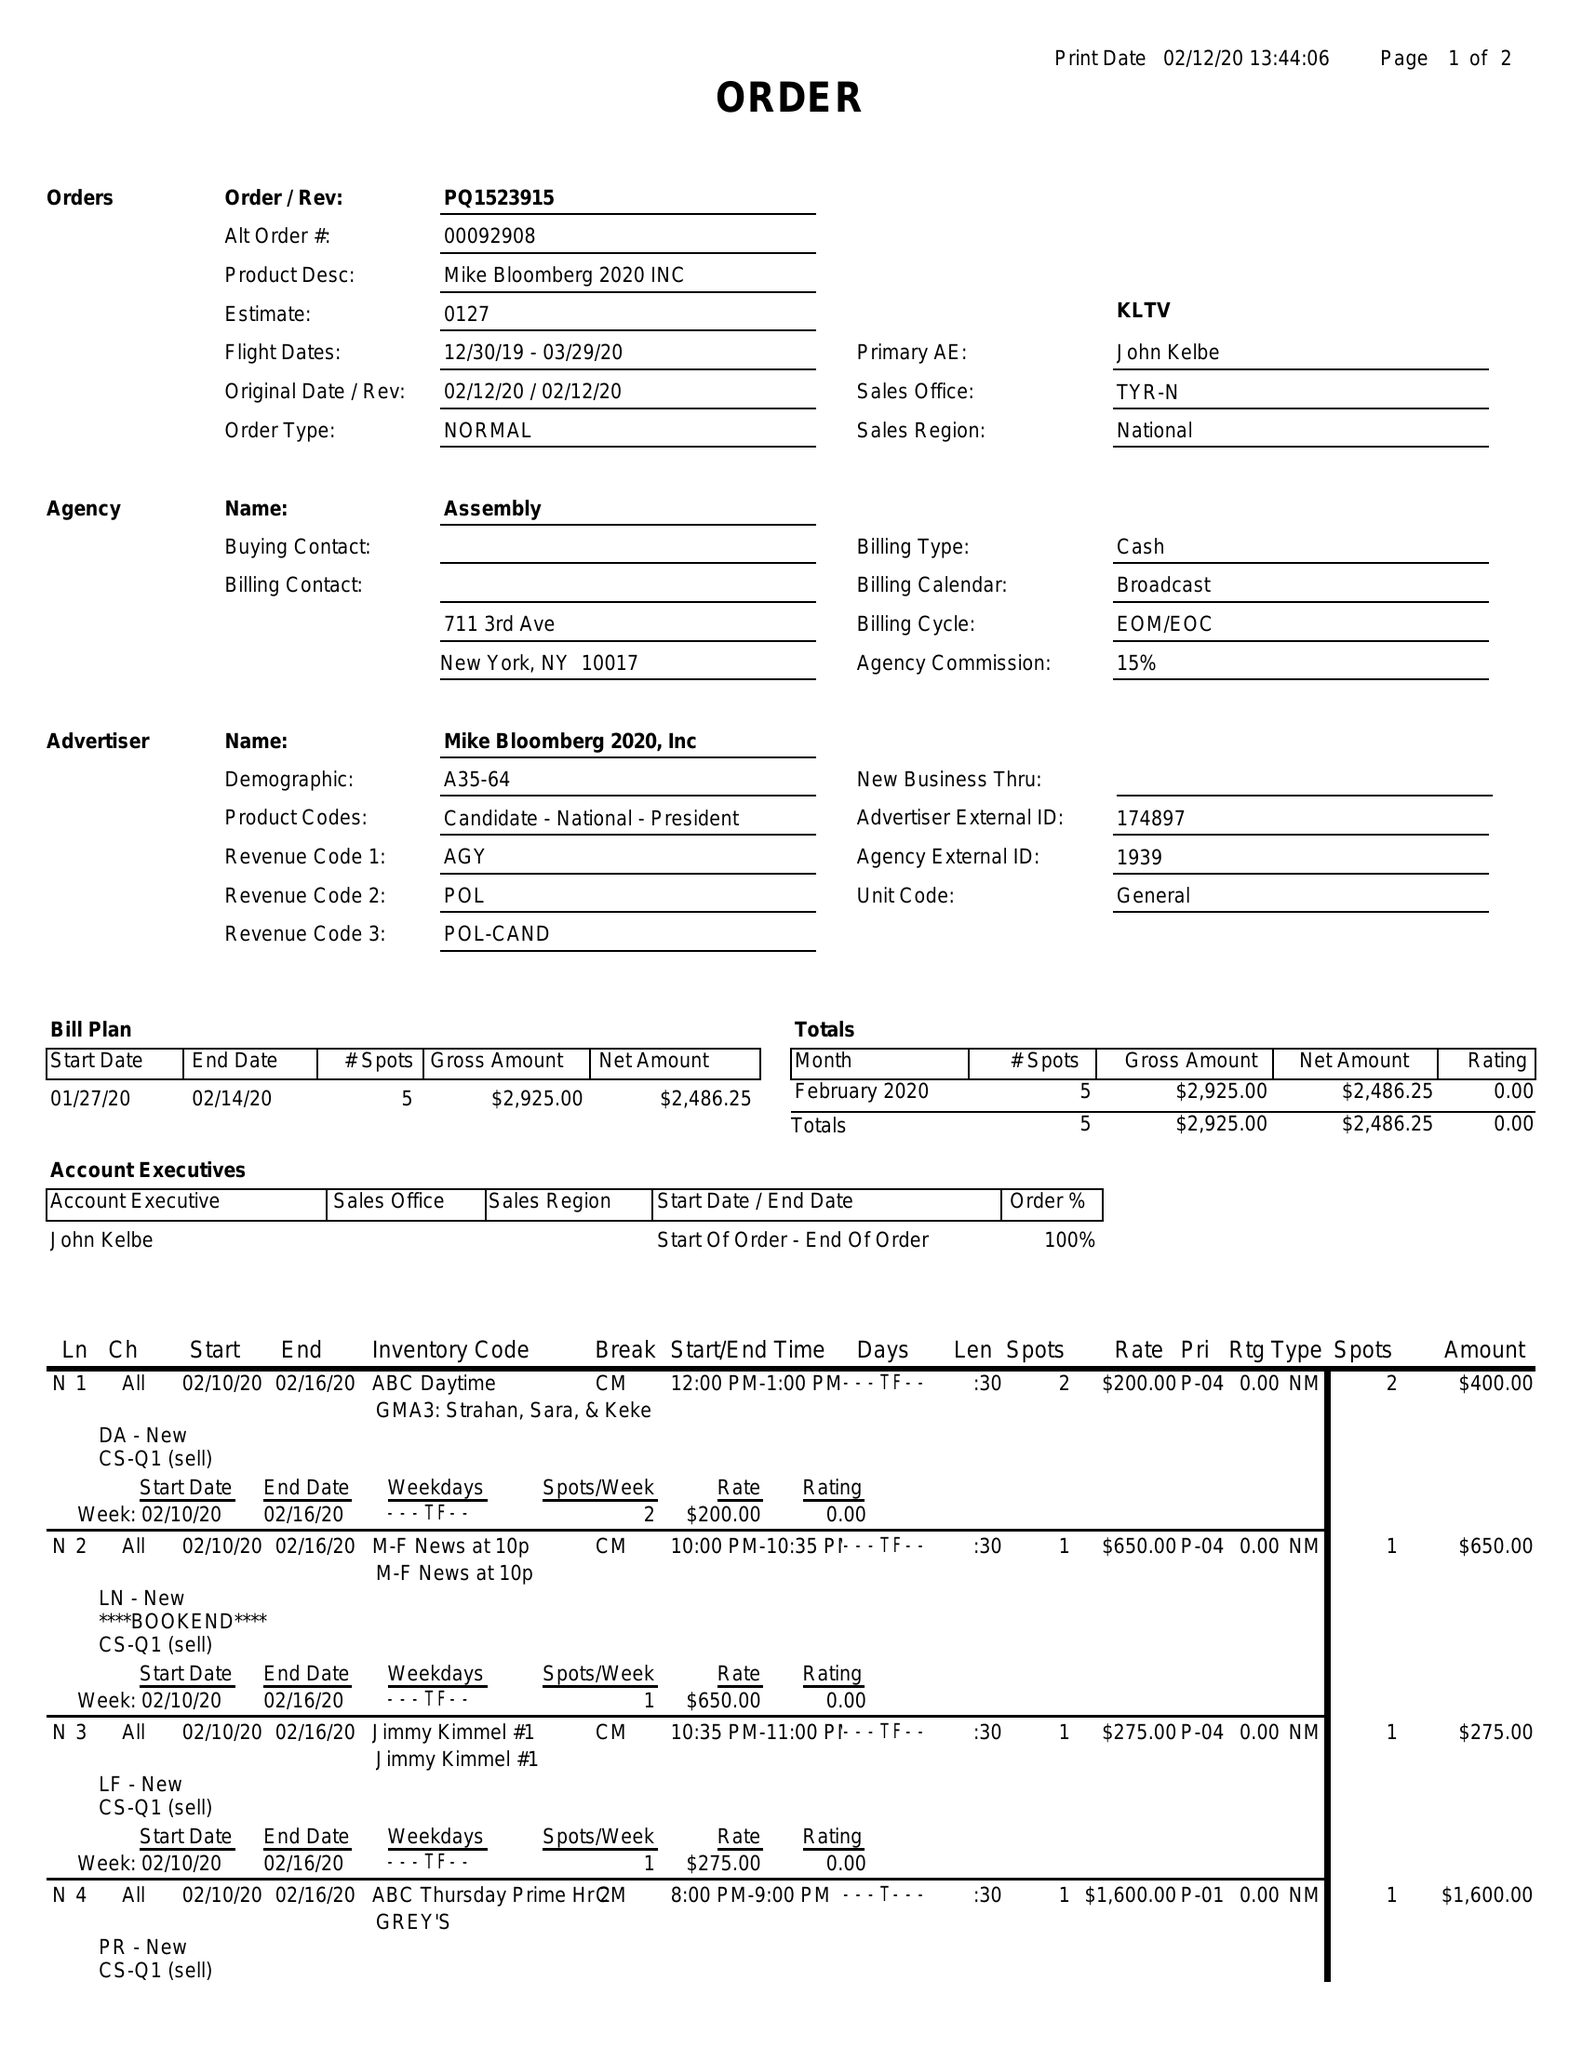What is the value for the contract_num?
Answer the question using a single word or phrase. PQ1523915 